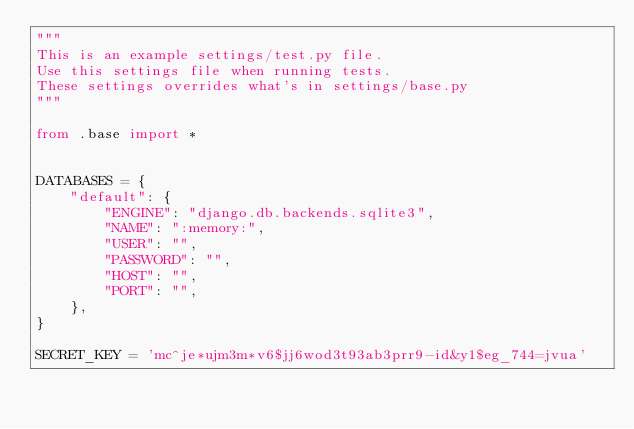<code> <loc_0><loc_0><loc_500><loc_500><_Python_>"""
This is an example settings/test.py file.
Use this settings file when running tests.
These settings overrides what's in settings/base.py
"""

from .base import *


DATABASES = {
    "default": {
        "ENGINE": "django.db.backends.sqlite3",
        "NAME": ":memory:",
        "USER": "",
        "PASSWORD": "",
        "HOST": "",
        "PORT": "",
    },
}

SECRET_KEY = 'mc^je*ujm3m*v6$jj6wod3t93ab3prr9-id&y1$eg_744=jvua'
</code> 